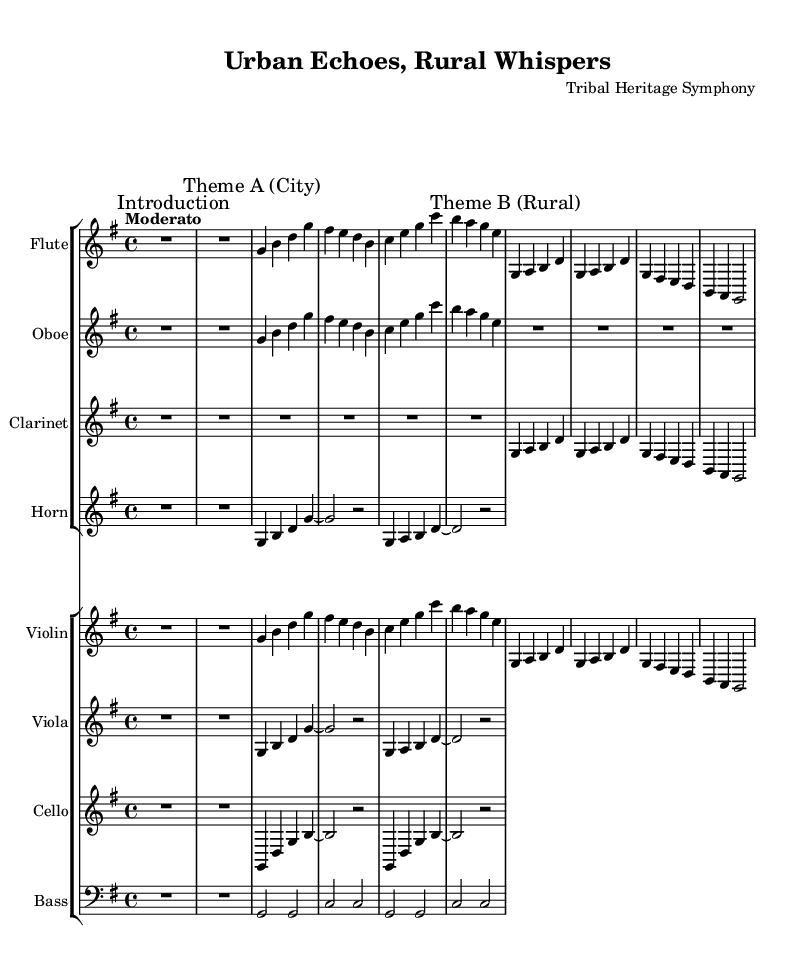What is the key signature of this music? The key signature is indicated at the beginning of the sheet music, specifically after the "\key" command. The "g" in "\key g \major" signifies that the music is in G major, which has one sharp.
Answer: G major What is the time signature of this piece? The time signature can be found in the first few measures of the music, represented by "\time 4/4". This means there are four beats in each measure, and the quarter note receives one beat.
Answer: 4/4 What is the tempo marking for this piece? The tempo marking is specified by the "\tempo" command. It is written as "Moderato," suggesting a moderate speed for the performance of the music.
Answer: Moderato How many distinct themes are present in the music? By examining the various sections and the commands present, we can identify two distinct themes: Theme A (City) and Theme B (Rural). Each theme is marked clearly in the flute part, indicating the transition between the two.
Answer: 2 Which instruments are featured in this symphony? The instruments are listed in the score. They include Flute, Oboe, Clarinet, Horn, Violin, Viola, Cello, and Bass. Each is part of their own staff group, organized in the composer’s arrangement.
Answer: Flute, Oboe, Clarinet, Horn, Violin, Viola, Cello, Bass What is the relationship between the city and rural themes? The themes represent contrasting aspects of life, where the city theme showcases urban sounds and rhythms, and the rural theme embodies natural and traditional elements. This contrast is vital to the symphony's narrative structure and evokes feelings tied to each setting.
Answer: Contrast What is the style of this symphony? Given the context provided by the title and the themes, this symphony embodies the Romantic era's characteristics, emphasizing emotional expression and contrasts through different musical themes that reflect urban and rural life.
Answer: Romantic 